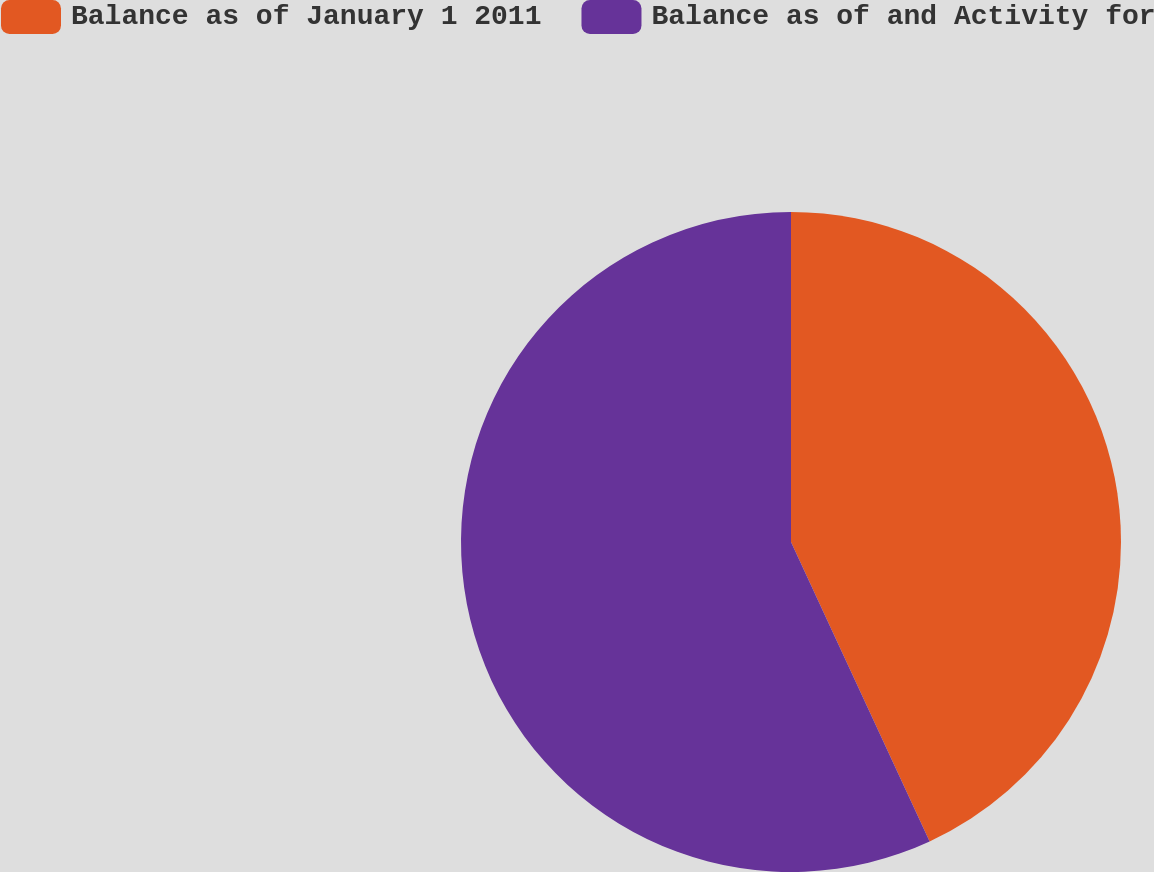Convert chart to OTSL. <chart><loc_0><loc_0><loc_500><loc_500><pie_chart><fcel>Balance as of January 1 2011<fcel>Balance as of and Activity for<nl><fcel>43.1%<fcel>56.9%<nl></chart> 